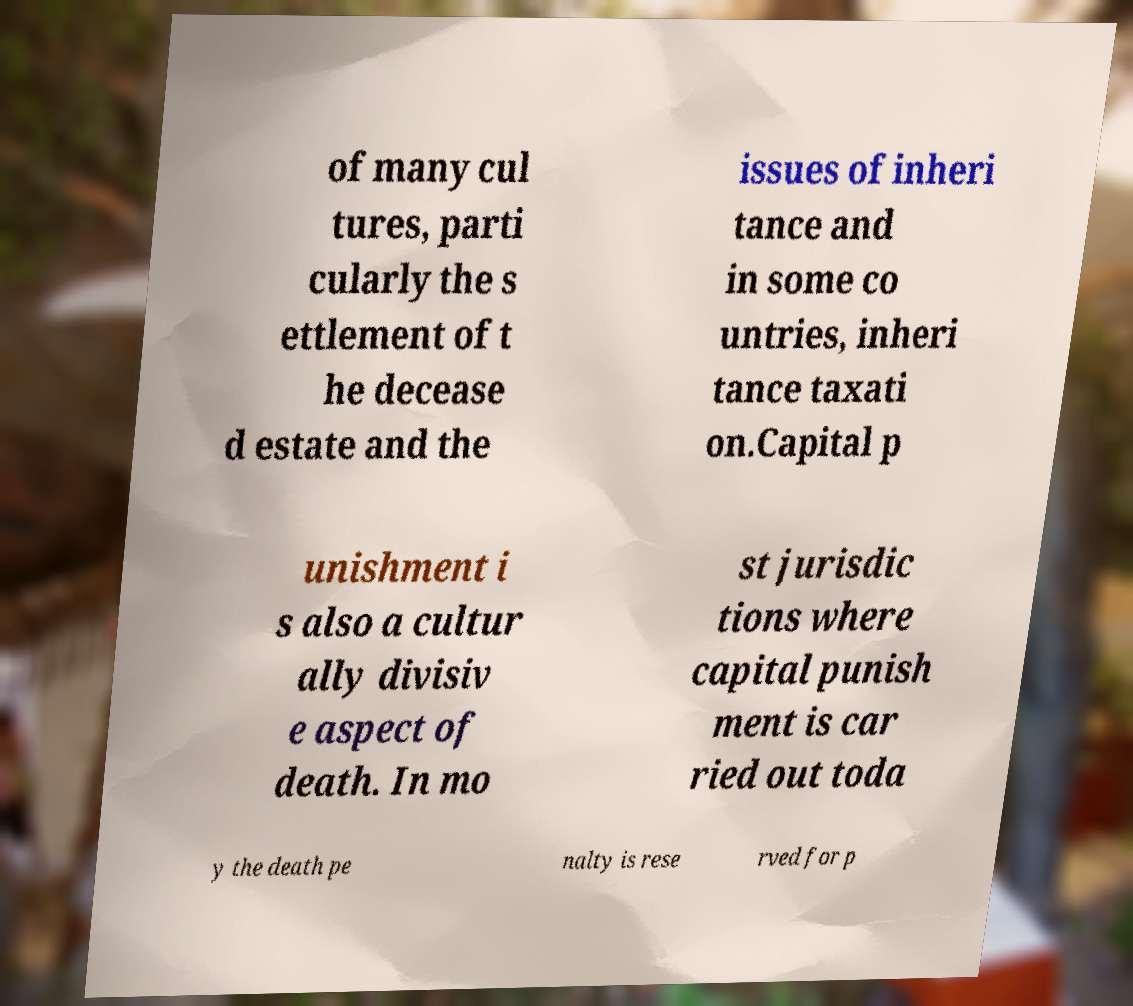Could you extract and type out the text from this image? of many cul tures, parti cularly the s ettlement of t he decease d estate and the issues of inheri tance and in some co untries, inheri tance taxati on.Capital p unishment i s also a cultur ally divisiv e aspect of death. In mo st jurisdic tions where capital punish ment is car ried out toda y the death pe nalty is rese rved for p 